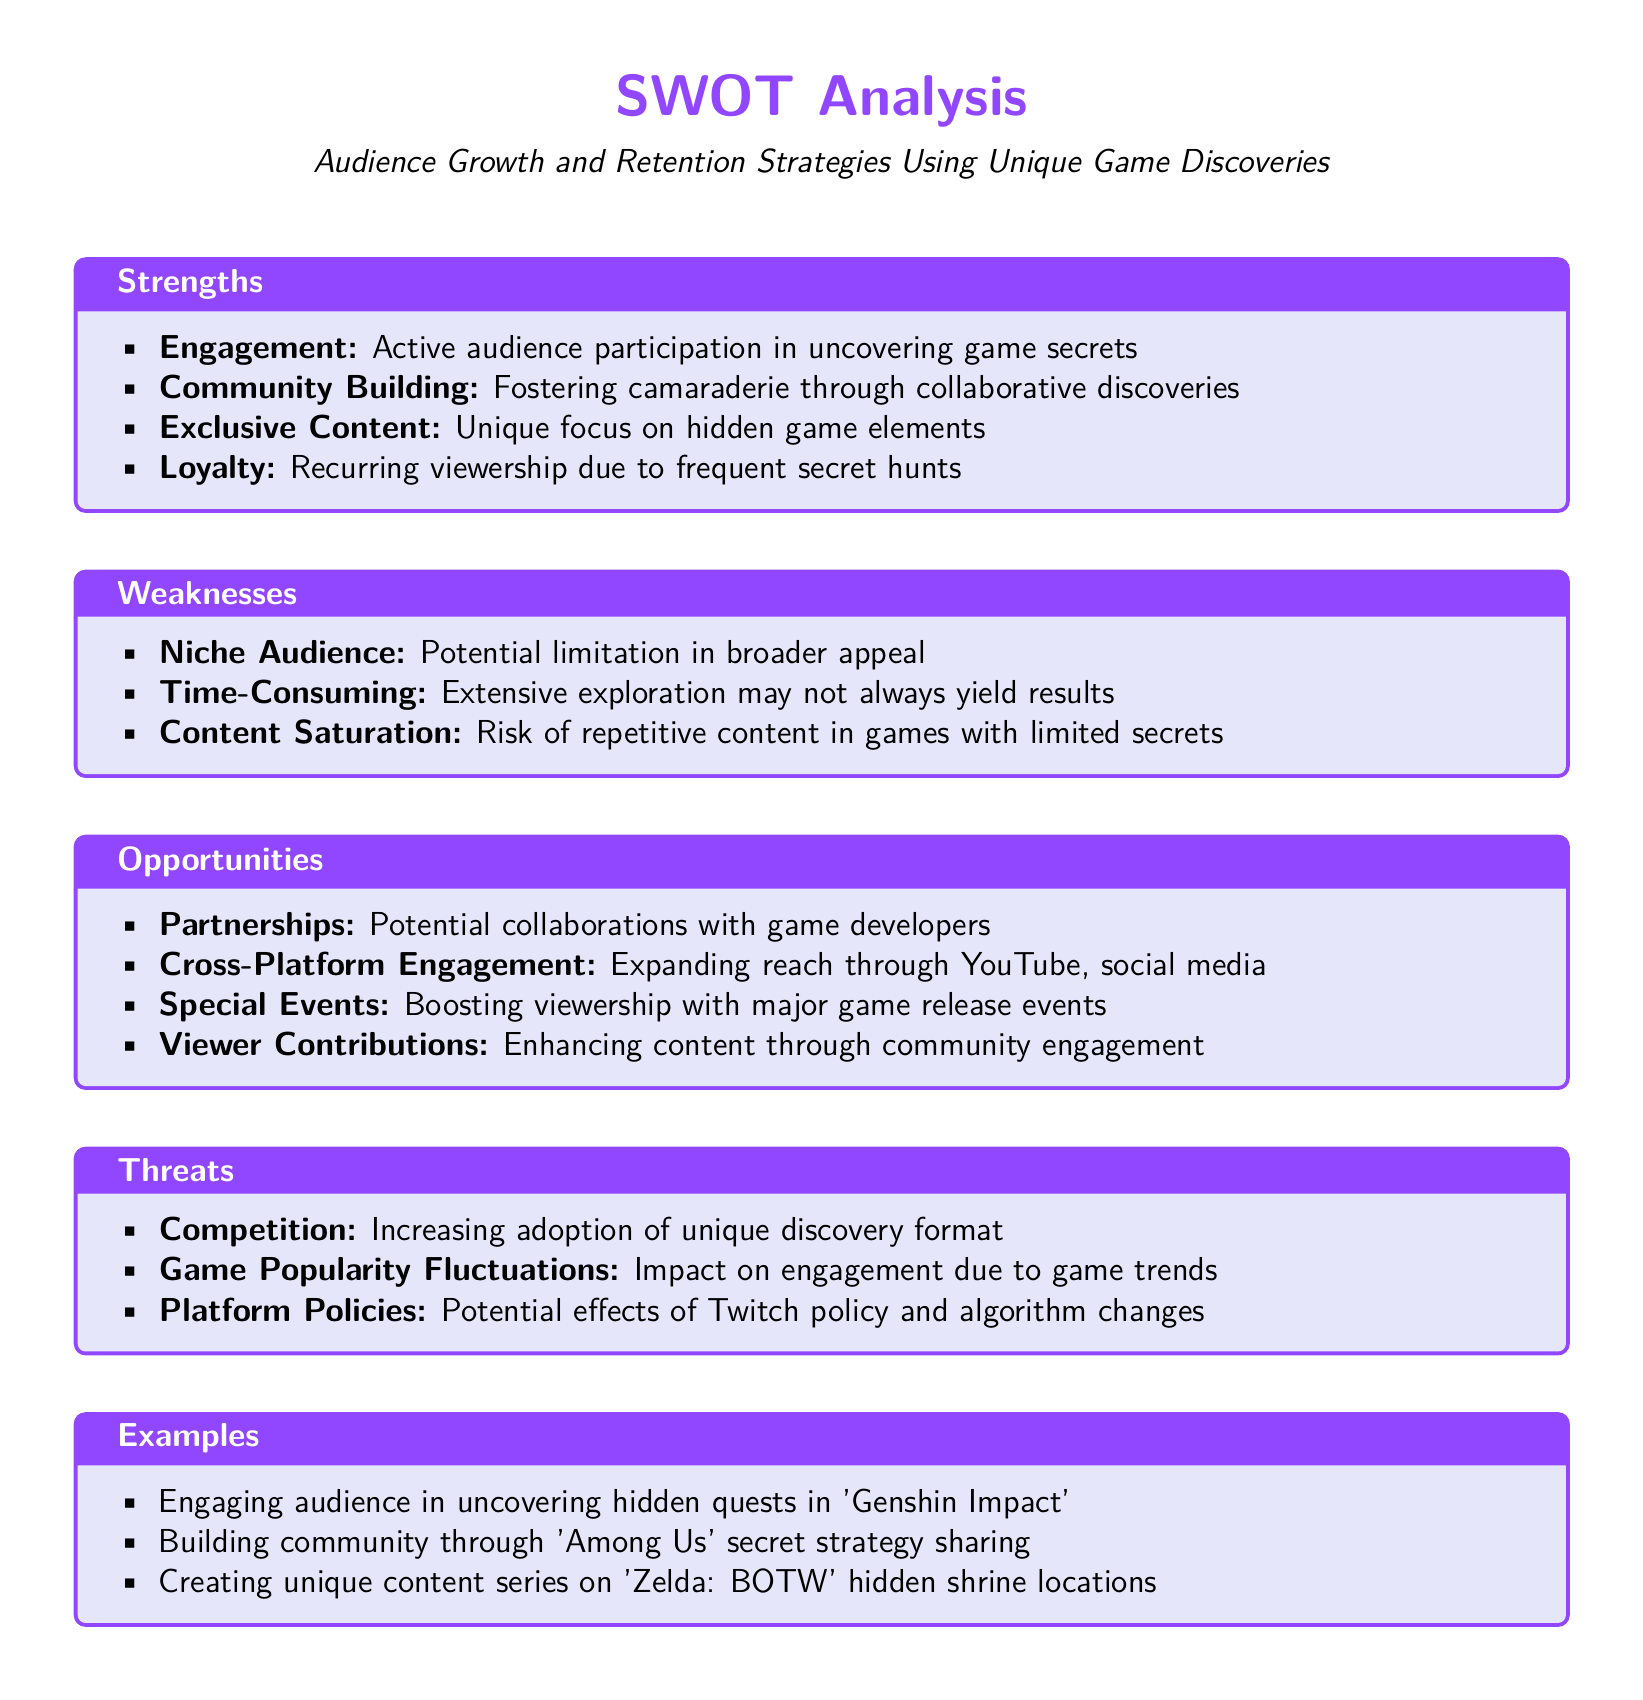What is the primary focus of the SWOT analysis? The SWOT analysis is centered around strategies for audience growth and retention using unique game discoveries.
Answer: audience growth and retention strategies using unique game discoveries How many strengths are listed in the document? The document contains a total of four strengths identified in the analysis.
Answer: 4 What is one weakness identified in the analysis? An identified weakness is the potential limitation in broader appeal due to a niche audience.
Answer: niche audience Name one opportunity for audience engagement mentioned. One opportunity for audience engagement is expanding reach through YouTube and social media.
Answer: cross-platform engagement What is a threat related to game popularity mentioned? The analysis notes that fluctuations in game popularity can impact audience engagement.
Answer: game popularity fluctuations List one example of audience engagement mentioned in the document. An example provided is engaging the audience in uncovering hidden quests in 'Genshin Impact'.
Answer: hidden quests in 'Genshin Impact' What is mentioned as a component of community building? Fostering camaraderie through collaborative discoveries is a component mentioned.
Answer: camaraderie through collaborative discoveries Which game is referenced for building community through secret strategy sharing? 'Among Us' is the game referenced for building community through secret strategy sharing.
Answer: Among Us 